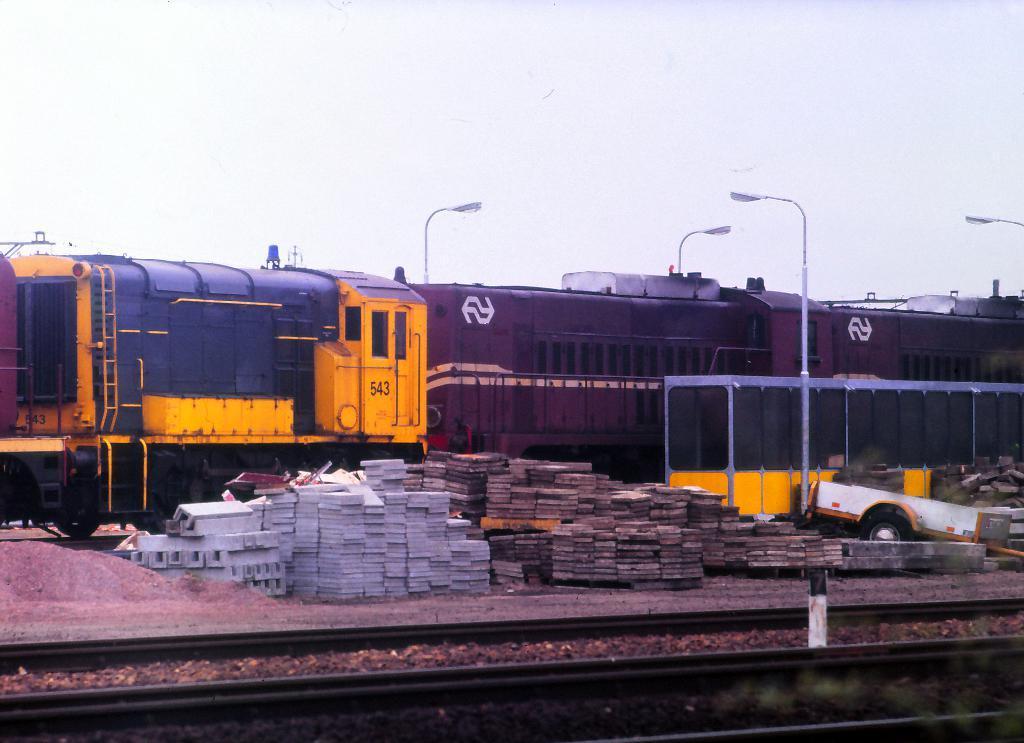Could you give a brief overview of what you see in this image? In this image we can see a train on the track. We can also see some marbles, sand, pole and the fence beside the train. we can also see the sky. 